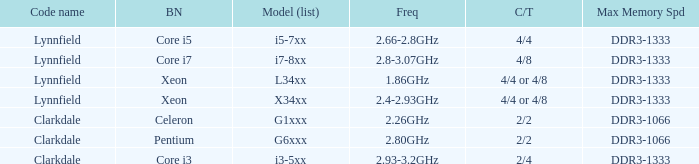What frequency does model L34xx use? 1.86GHz. 